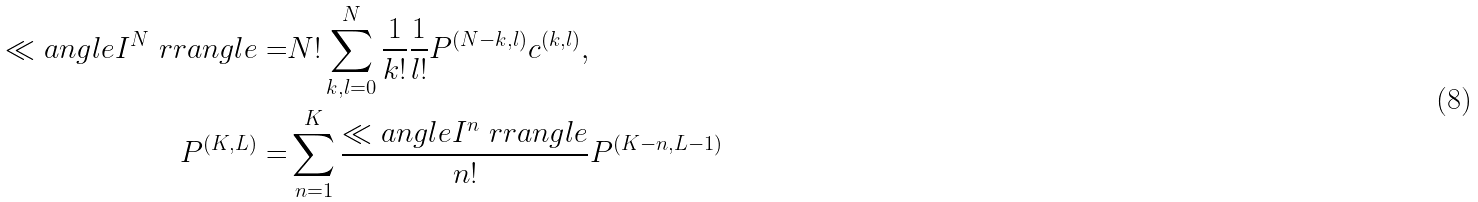<formula> <loc_0><loc_0><loc_500><loc_500>\ll a n g l e I ^ { N } \ r r a n g l e = & N ! \sum _ { k , l = 0 } ^ { N } \frac { 1 } { k ! } \frac { 1 } { l ! } P ^ { ( N - k , l ) } c ^ { ( k , l ) } , \\ P ^ { ( K , L ) } = & \sum _ { n = 1 } ^ { K } \frac { \ll a n g l e I ^ { n } \ r r a n g l e } { n ! } P ^ { ( K - n , L - 1 ) }</formula> 